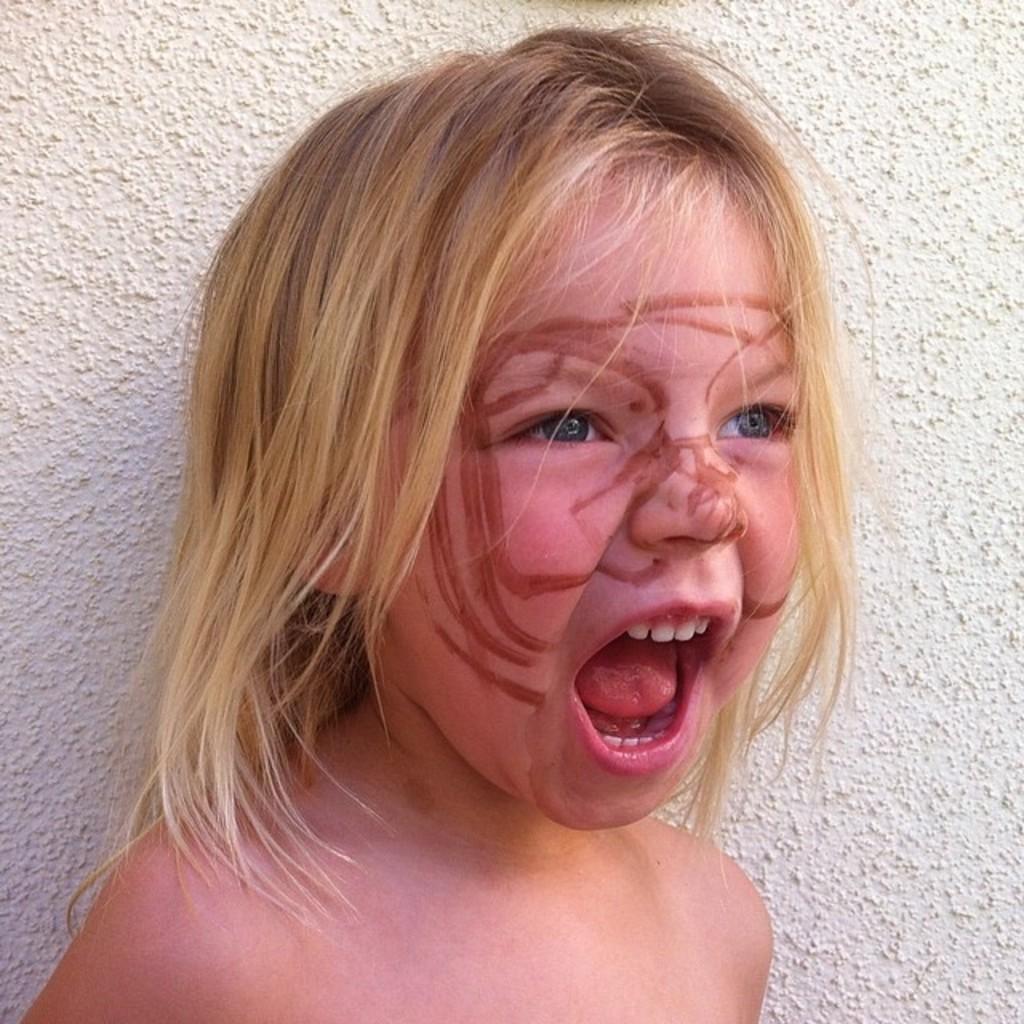How would you summarize this image in a sentence or two? In the foreground of this image, there is a girl with opened mouth and few sketch marks on her face. In the background, there is wall. 